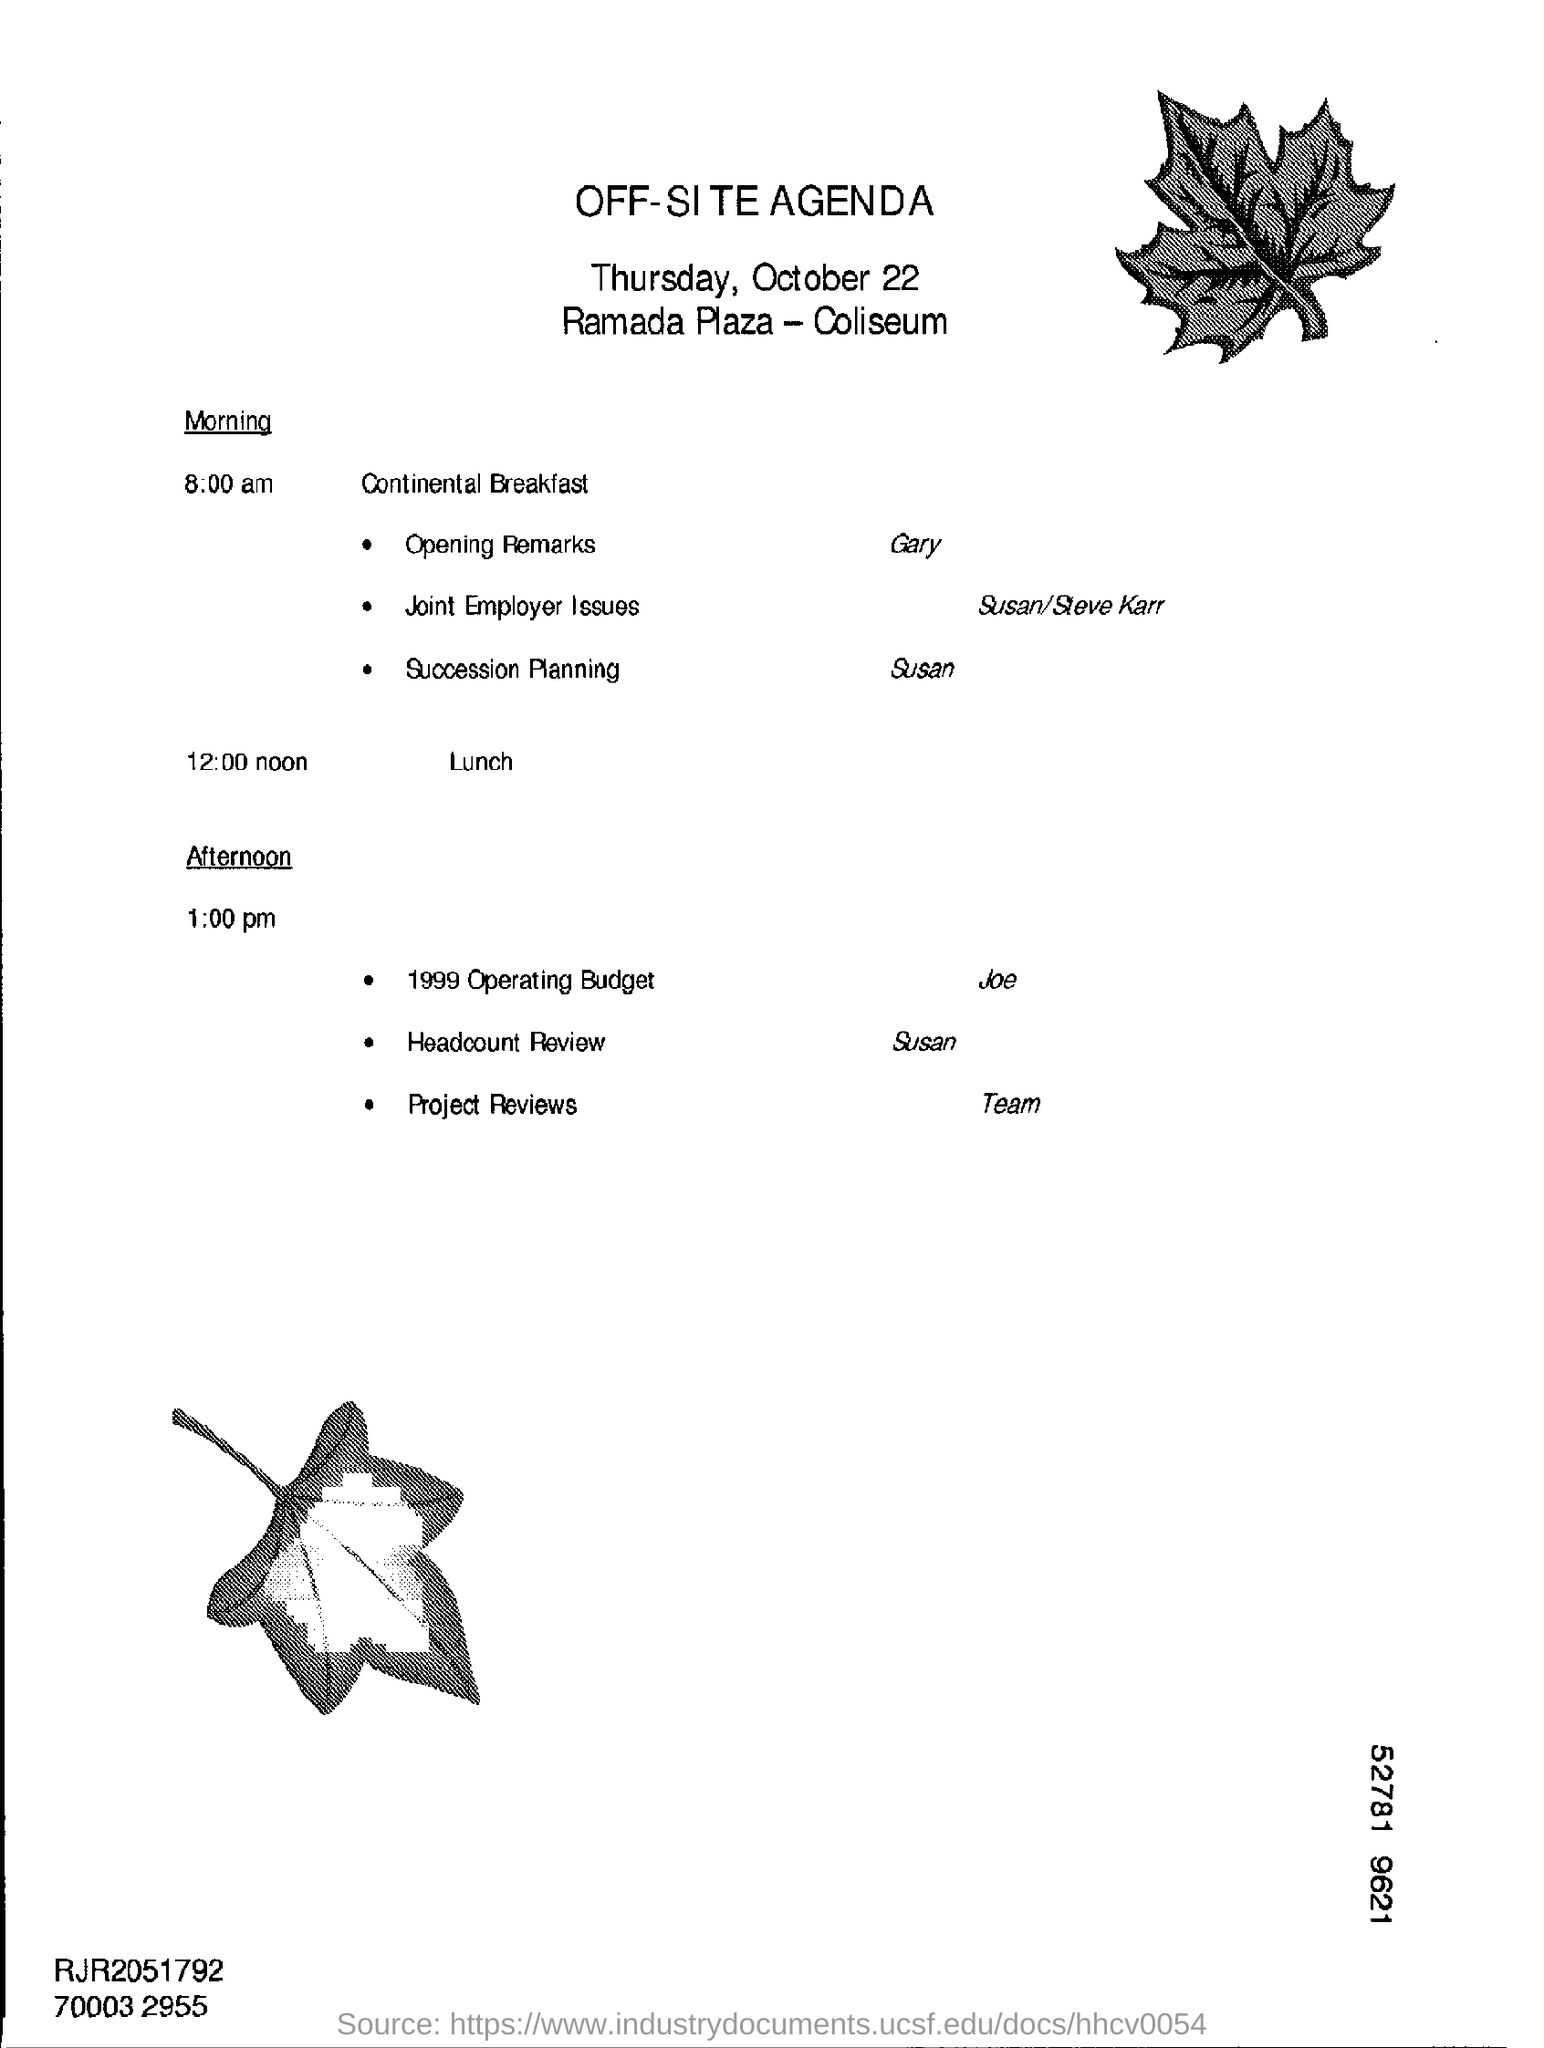What is the Title of the document ?
Give a very brief answer. Off-Site Agenda. What time is the lunch scheduled?
Provide a short and direct response. 12:00 noon. What is the Lunch Timing ?
Provide a succinct answer. 12:00 noon. 